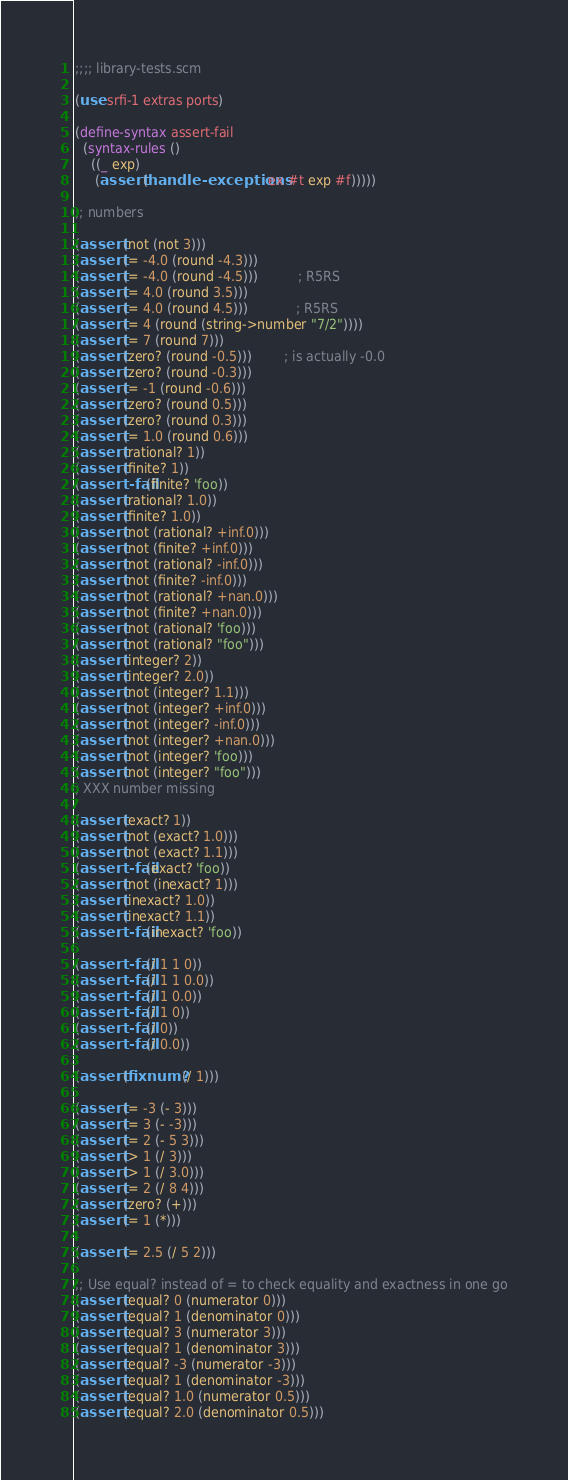Convert code to text. <code><loc_0><loc_0><loc_500><loc_500><_Scheme_>;;;; library-tests.scm

(use srfi-1 extras ports)

(define-syntax assert-fail
  (syntax-rules ()
    ((_ exp)
     (assert (handle-exceptions ex #t exp #f)))))

;; numbers

(assert (not (not 3)))
(assert (= -4.0 (round -4.3)))
(assert (= -4.0 (round -4.5)))          ; R5RS
(assert (= 4.0 (round 3.5)))
(assert (= 4.0 (round 4.5)))            ; R5RS
(assert (= 4 (round (string->number "7/2"))))
(assert (= 7 (round 7)))
(assert (zero? (round -0.5))) 		; is actually -0.0
(assert (zero? (round -0.3)))
(assert (= -1 (round -0.6)))
(assert (zero? (round 0.5)))
(assert (zero? (round 0.3)))
(assert (= 1.0 (round 0.6)))
(assert (rational? 1))
(assert (finite? 1))
(assert-fail (finite? 'foo))
(assert (rational? 1.0))
(assert (finite? 1.0))
(assert (not (rational? +inf.0)))
(assert (not (finite? +inf.0)))
(assert (not (rational? -inf.0)))
(assert (not (finite? -inf.0)))
(assert (not (rational? +nan.0)))
(assert (not (finite? +nan.0)))
(assert (not (rational? 'foo)))
(assert (not (rational? "foo")))
(assert (integer? 2))
(assert (integer? 2.0))
(assert (not (integer? 1.1)))
(assert (not (integer? +inf.0)))
(assert (not (integer? -inf.0)))
(assert (not (integer? +nan.0)))
(assert (not (integer? 'foo)))
(assert (not (integer? "foo")))
; XXX number missing

(assert (exact? 1))
(assert (not (exact? 1.0)))
(assert (not (exact? 1.1)))
(assert-fail (exact? 'foo))
(assert (not (inexact? 1)))
(assert (inexact? 1.0))
(assert (inexact? 1.1))
(assert-fail (inexact? 'foo))

(assert-fail (/ 1 1 0))
(assert-fail (/ 1 1 0.0))
(assert-fail (/ 1 0.0))
(assert-fail (/ 1 0))
(assert-fail (/ 0))
(assert-fail (/ 0.0))

(assert (fixnum? (/ 1)))

(assert (= -3 (- 3)))
(assert (= 3 (- -3)))
(assert (= 2 (- 5 3)))
(assert (> 1 (/ 3)))
(assert (> 1 (/ 3.0)))
(assert (= 2 (/ 8 4)))
(assert (zero? (+)))
(assert (= 1 (*)))

(assert (= 2.5 (/ 5 2)))

;; Use equal? instead of = to check equality and exactness in one go
(assert (equal? 0 (numerator 0)))
(assert (equal? 1 (denominator 0)))
(assert (equal? 3 (numerator 3)))
(assert (equal? 1 (denominator 3)))
(assert (equal? -3 (numerator -3)))
(assert (equal? 1 (denominator -3)))
(assert (equal? 1.0 (numerator 0.5)))
(assert (equal? 2.0 (denominator 0.5)))</code> 